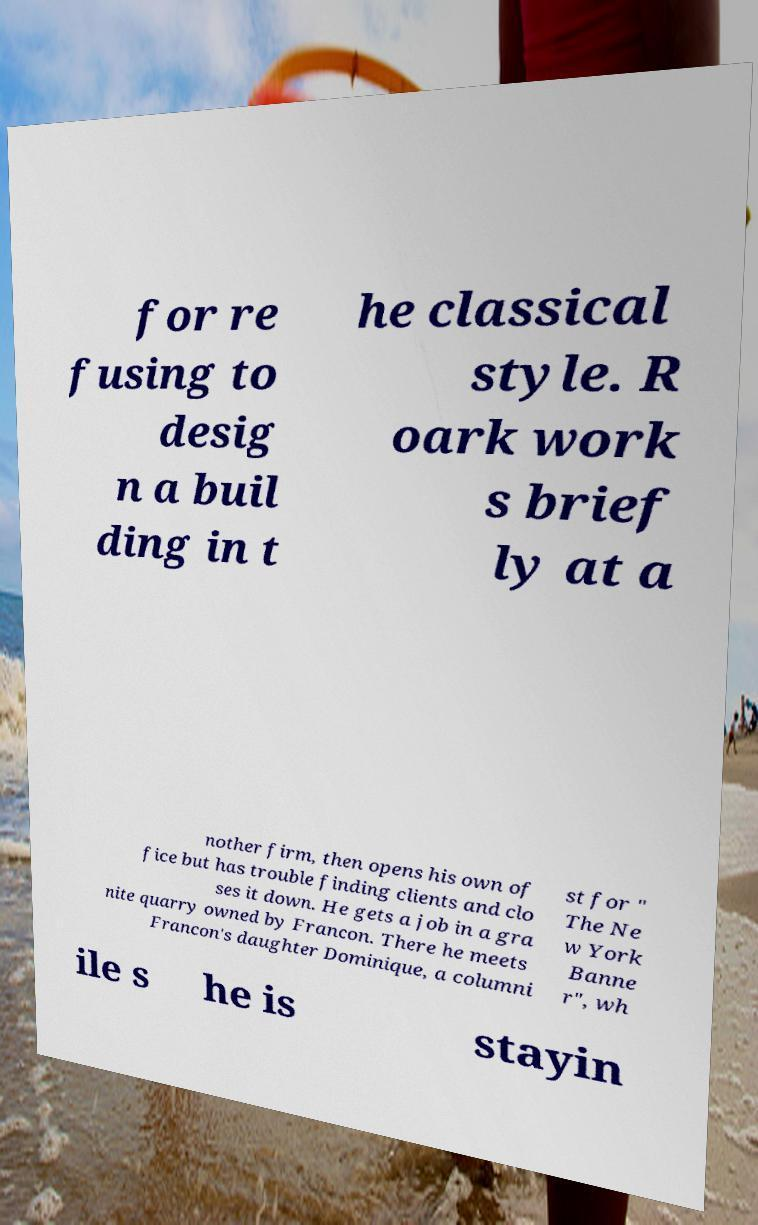Can you accurately transcribe the text from the provided image for me? for re fusing to desig n a buil ding in t he classical style. R oark work s brief ly at a nother firm, then opens his own of fice but has trouble finding clients and clo ses it down. He gets a job in a gra nite quarry owned by Francon. There he meets Francon's daughter Dominique, a columni st for " The Ne w York Banne r", wh ile s he is stayin 